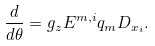Convert formula to latex. <formula><loc_0><loc_0><loc_500><loc_500>\frac { d } { d \theta } = g _ { z } E ^ { m , i } q _ { m } D _ { x _ { i } } .</formula> 